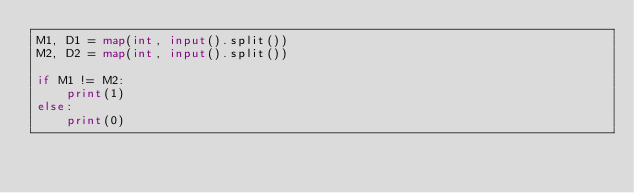<code> <loc_0><loc_0><loc_500><loc_500><_Python_>M1, D1 = map(int, input().split())
M2, D2 = map(int, input().split())

if M1 != M2:
    print(1)
else:
    print(0)
</code> 